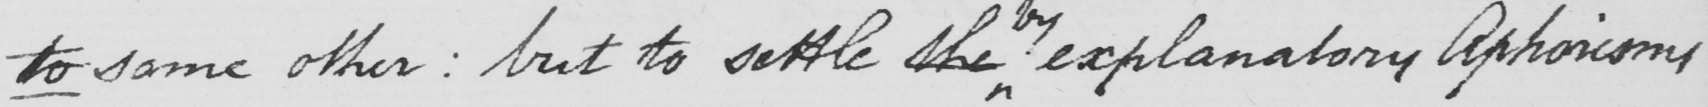What text is written in this handwritten line? to some other :  but to settle the explanatory Aphorisms 